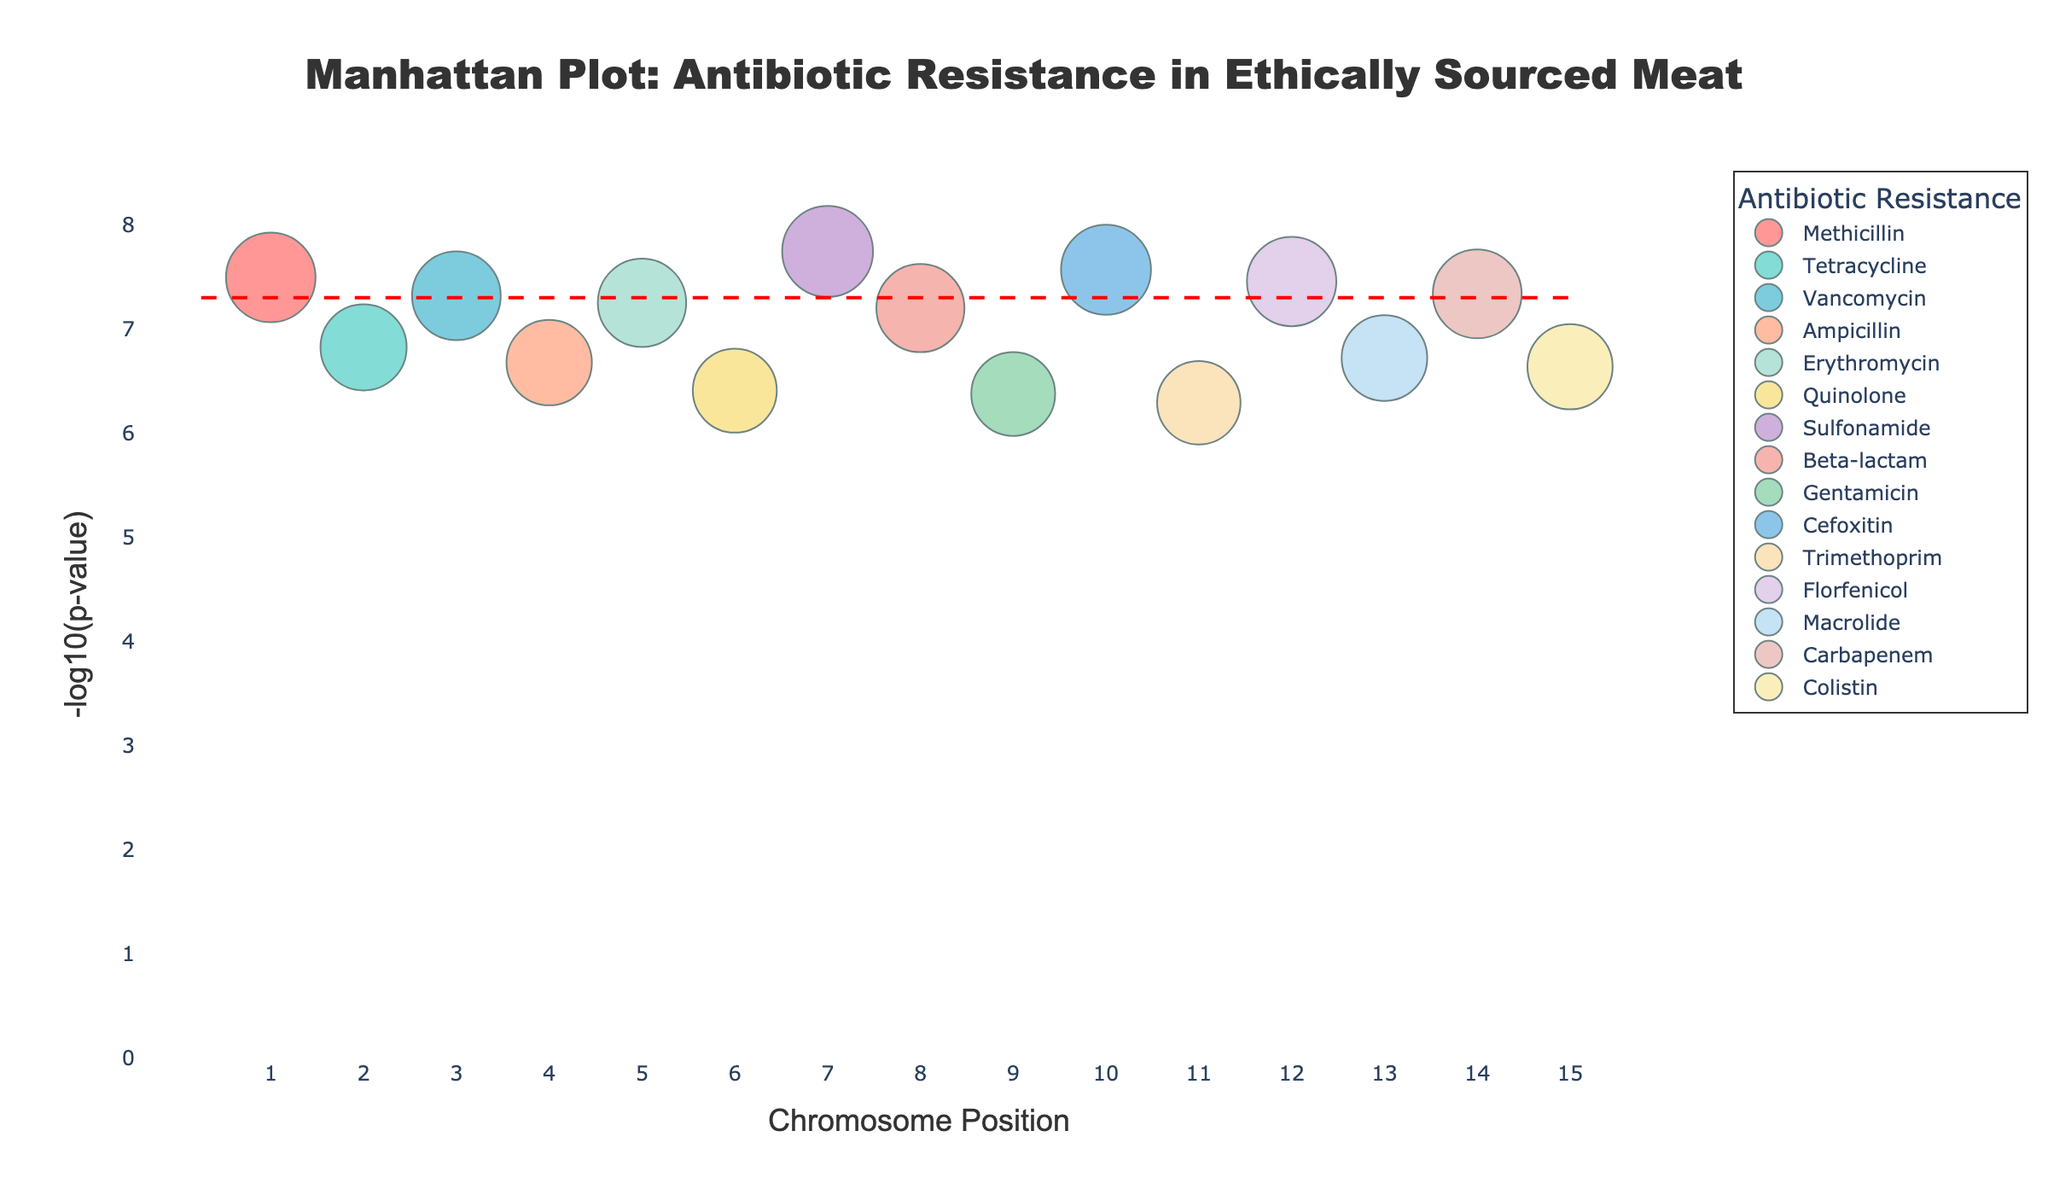what is the title of the plot? The title is prominently placed at the top center of the plot and reads "Manhattan Plot: Antibiotic Resistance in Ethically Sourced Meat".
Answer: Manhattan Plot: Antibiotic Resistance in Ethically Sourced Meat How many data points are associated with Methicillin resistance? Each data point in the plot represents a specific chromosome position associated with an antibiotic resistance gene. Looking at the legend and correlating it with the markers, we can see that Methicillin resistance has only one marker on the plot.
Answer: 1 Which gene is associated with the lowest p-value, and what is its antibiotic resistance type? The lowest p-value will correspond to the highest point in terms of -log10(p). From the plot, the highest point visibly belongs to Sulfonamide resistance, associated with the gene Sul1.
Answer: Sul1, Sulfonamide Are there any antibiotic resistance types with more than one associated gene shown in the plot? Looking through the legend and markers in the plot, each resistance type is represented by a unique color and single marker. This implies that no resistance type has more than one associated gene in the plot.
Answer: No Which chromosome position corresponds to the gene associated with Carbapenem resistance? The gene associated with Carbapenem resistance is OXA-48. From the plot, looking for the label OXA-48, it is shown at the chromosome position 275,000,000 indicated on the x-axis.
Answer: 275,000,000 What is the significance threshold marked in the plot, and which antibiotic resistance genes are below this threshold? The significance threshold is indicated by a dashed red line. Visually, the genes (points) below this line will be considered significant. The genes are MRSA1 (Methicillin), TetM (Tetracycline), VanA (Vancomycin), AmpC (Ampicillin), ErmB (Erythromycin), Sul1 (Sulfonamide), BlaTEM (Beta-lactam), CfxA (Cefoxitin), DfrA (Trimethoprim), FloR (Florfenicol), and OXA-48 (Carbapenem).
Answer: MRSA1, TetM, VanA, AmpC, ErmB, Sul1, BlaTEM, CfxA, DfrA, FloR, OXA-48 Which gene had the least significant p-value, and what antibiotic is it resistant to? The least significant p-value corresponds to the point lowest on the y-axis. By inspecting the plot, it's clear that DfrA (Trimethoprim) is the point with the lowest -log10(p) value.
Answer: DfrA, Trimethoprim What is the color used to represent genes resistant to Quinolone? By referring to the legend and matching it with the markers in the plot, Quinolone resistance is represented by the color yellow.
Answer: Yellow Which chromosome has the highest number of antibiotic resistance genes mapped on it? Examining the x-axis, each chromosome position has only one associated gene, thus no chromosome has multiple antibiotic resistance genes mapped on it according to this plot.
Answer: N/A 